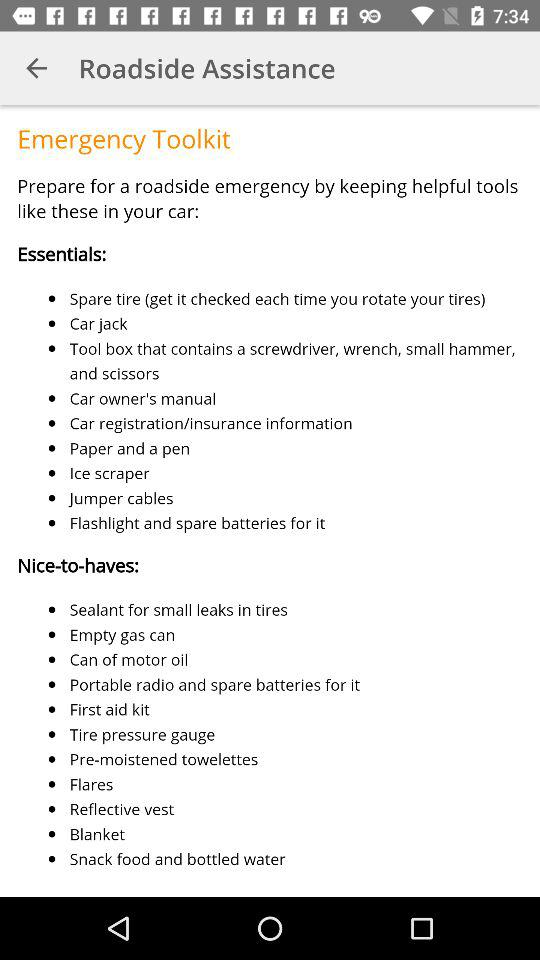What are the essential tools that are required in a car? The essential tools are a spare tire, a car jack, a toolbox that contains a screwdriver, a wrench, a small hammer, scissors, the car owner's manual, car registration/insurance information, paper, a pen, an ice scraper, jumper cables, a flashlight and spare batteries for it. 